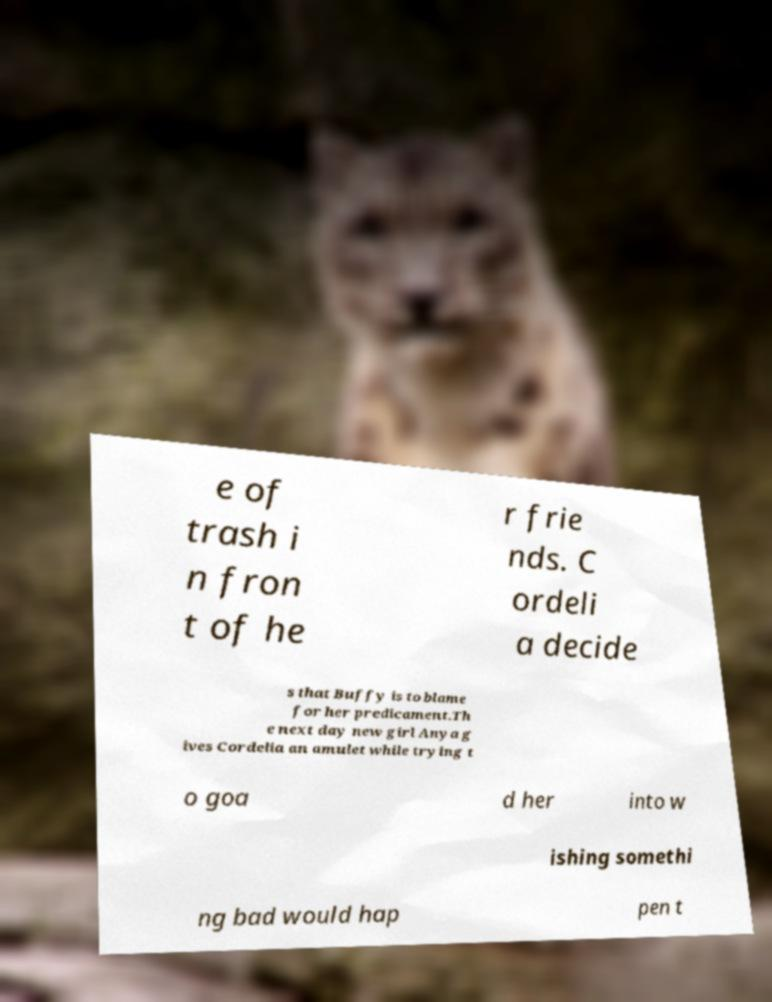Can you accurately transcribe the text from the provided image for me? e of trash i n fron t of he r frie nds. C ordeli a decide s that Buffy is to blame for her predicament.Th e next day new girl Anya g ives Cordelia an amulet while trying t o goa d her into w ishing somethi ng bad would hap pen t 